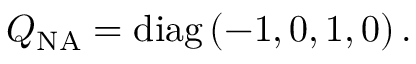Convert formula to latex. <formula><loc_0><loc_0><loc_500><loc_500>Q _ { N A } = d i a g \, ( - 1 , 0 , 1 , 0 ) \, .</formula> 